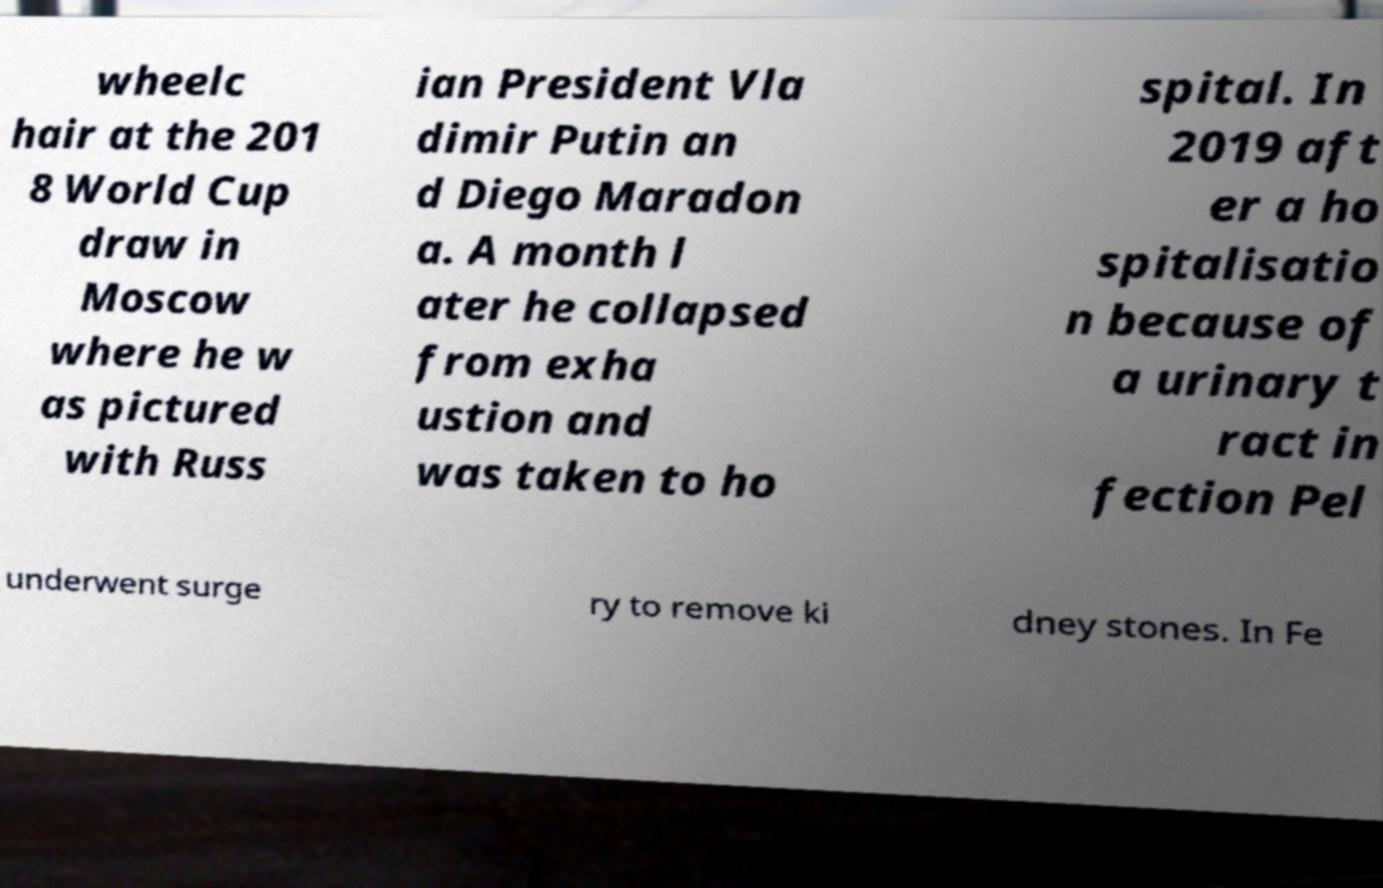Could you assist in decoding the text presented in this image and type it out clearly? wheelc hair at the 201 8 World Cup draw in Moscow where he w as pictured with Russ ian President Vla dimir Putin an d Diego Maradon a. A month l ater he collapsed from exha ustion and was taken to ho spital. In 2019 aft er a ho spitalisatio n because of a urinary t ract in fection Pel underwent surge ry to remove ki dney stones. In Fe 